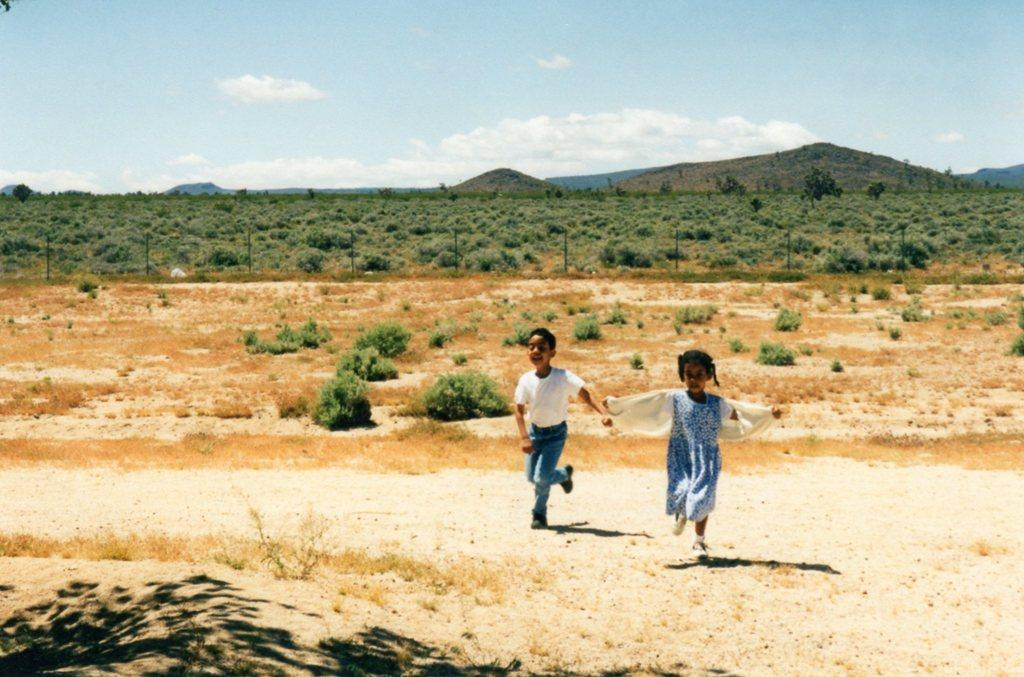Who is present in the image? There are kids in the image. What are the kids doing? The kids are running. What can be seen in the background of the image? There are plants in the background of the image. How would you describe the weather based on the image? The sky is cloudy in the image, suggesting a potentially overcast or cloudy day. What type of zipper can be seen on the plants in the image? There are no zippers present on the plants in the image. What metal objects can be seen on the kids' toes in the image? There are no metal objects visible on the kids' toes in the image. 